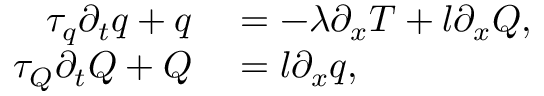Convert formula to latex. <formula><loc_0><loc_0><loc_500><loc_500>\begin{array} { r l } { \tau _ { q } \partial _ { t } q + q } & = - \lambda \partial _ { x } T + l \partial _ { x } Q , } \\ { \tau _ { Q } \partial _ { t } Q + Q } & = l \partial _ { x } q , } \end{array}</formula> 